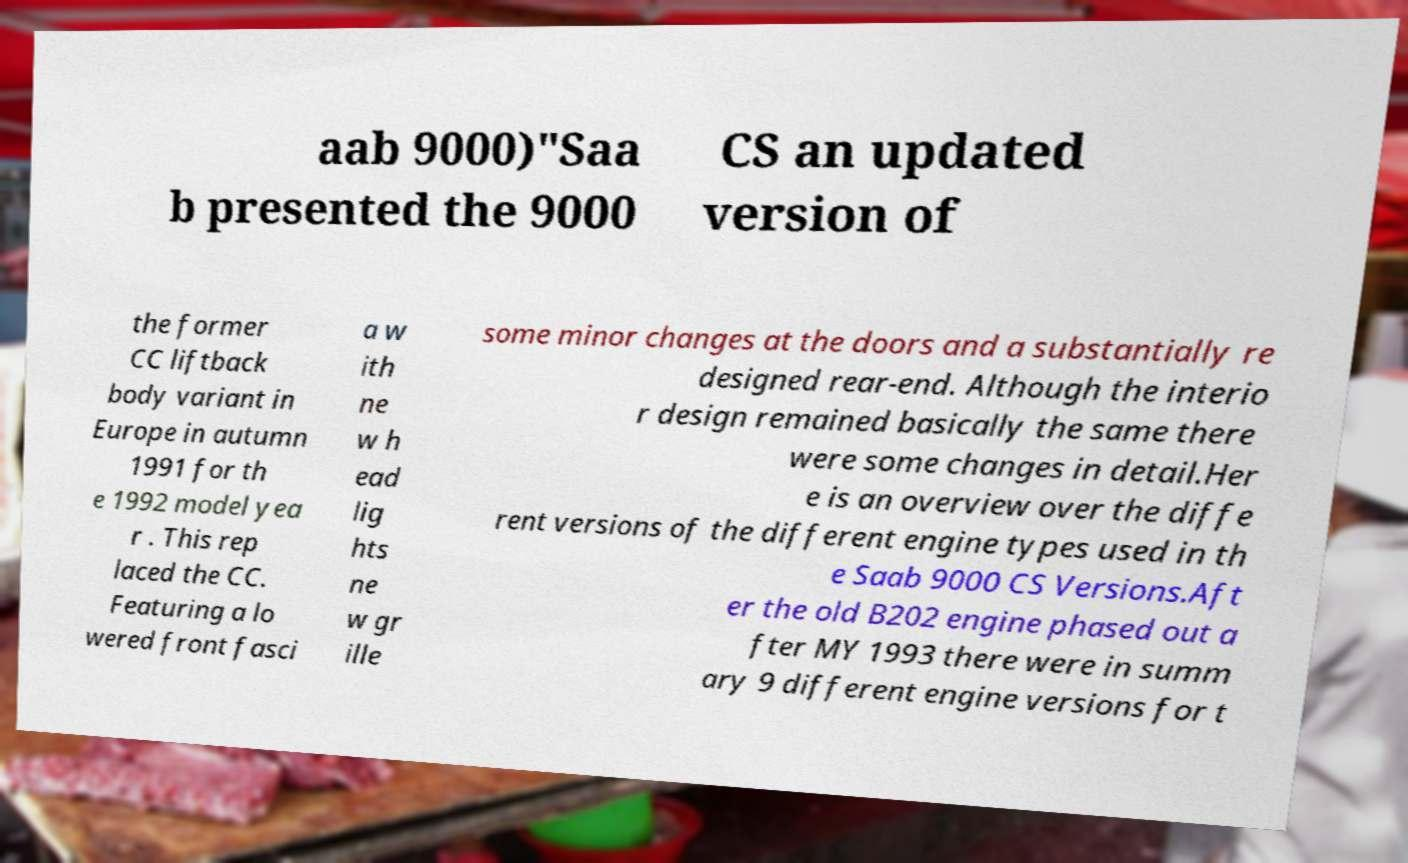Could you extract and type out the text from this image? aab 9000)"Saa b presented the 9000 CS an updated version of the former CC liftback body variant in Europe in autumn 1991 for th e 1992 model yea r . This rep laced the CC. Featuring a lo wered front fasci a w ith ne w h ead lig hts ne w gr ille some minor changes at the doors and a substantially re designed rear-end. Although the interio r design remained basically the same there were some changes in detail.Her e is an overview over the diffe rent versions of the different engine types used in th e Saab 9000 CS Versions.Aft er the old B202 engine phased out a fter MY 1993 there were in summ ary 9 different engine versions for t 